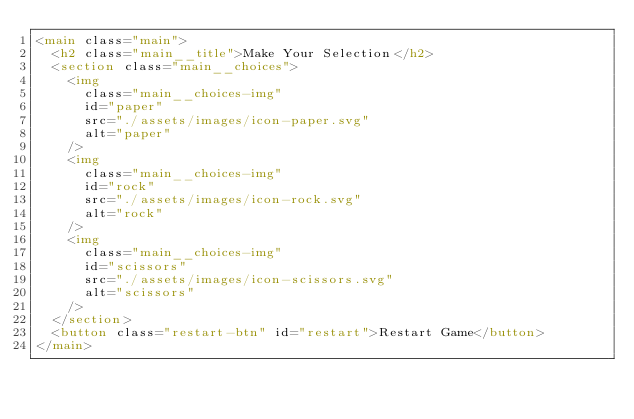Convert code to text. <code><loc_0><loc_0><loc_500><loc_500><_HTML_><main class="main">
  <h2 class="main__title">Make Your Selection</h2>
  <section class="main__choices">
    <img
      class="main__choices-img"
      id="paper"
      src="./assets/images/icon-paper.svg"
      alt="paper"
    />
    <img
      class="main__choices-img"
      id="rock"
      src="./assets/images/icon-rock.svg"
      alt="rock"
    />
    <img
      class="main__choices-img"
      id="scissors"
      src="./assets/images/icon-scissors.svg"
      alt="scissors"
    />
  </section>
  <button class="restart-btn" id="restart">Restart Game</button>
</main>
</code> 